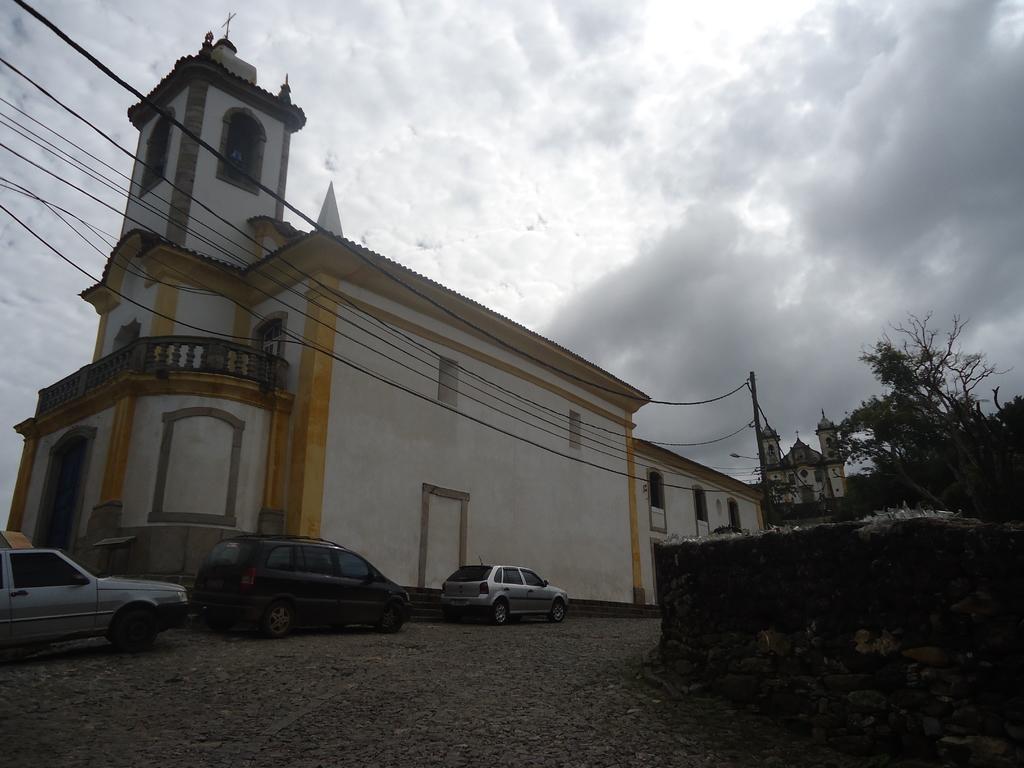In one or two sentences, can you explain what this image depicts? In the foreground of the picture there are gravel stones. In the center of the picture it is a cathedral and there are cables and current pole. On the left there are cars. On the right there are trees and a wall. At the top it is sky, sky is cloudy. 